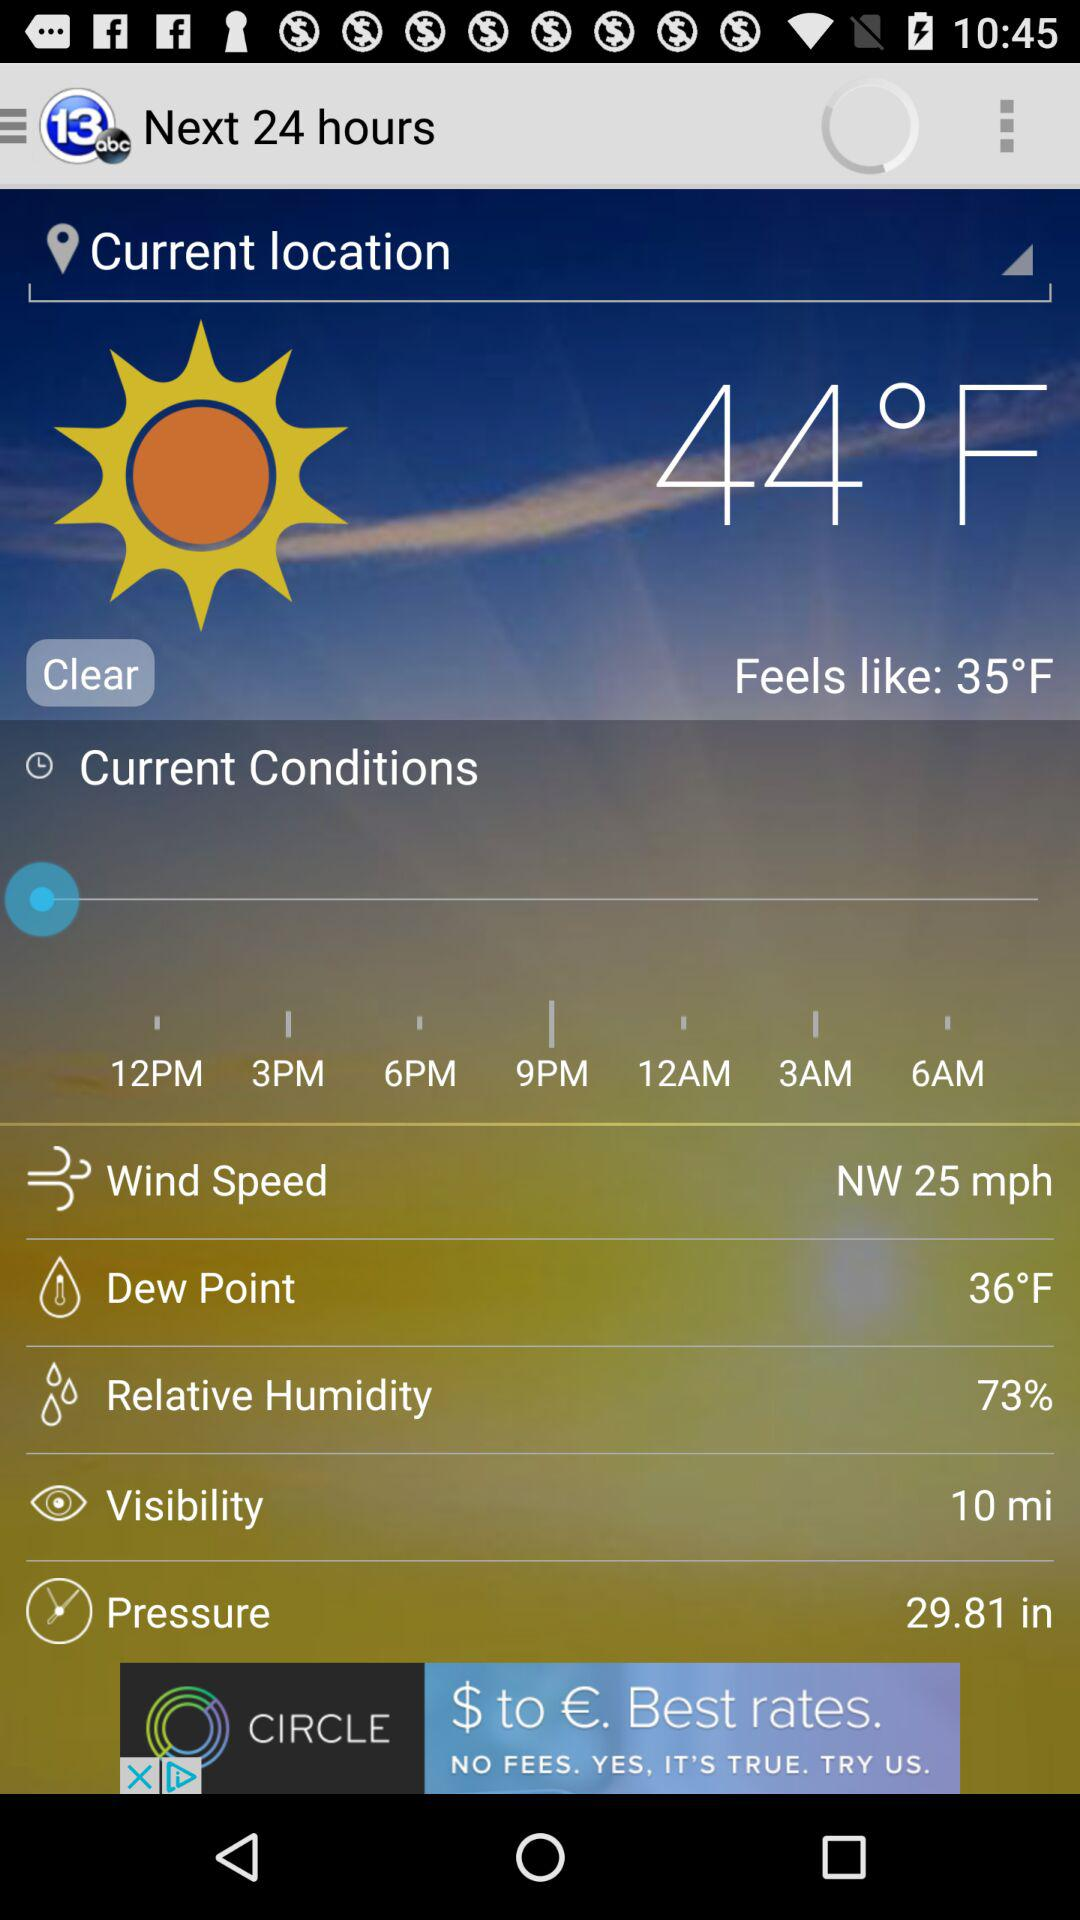What is the wind speed? The wind speed is 25 mph. 